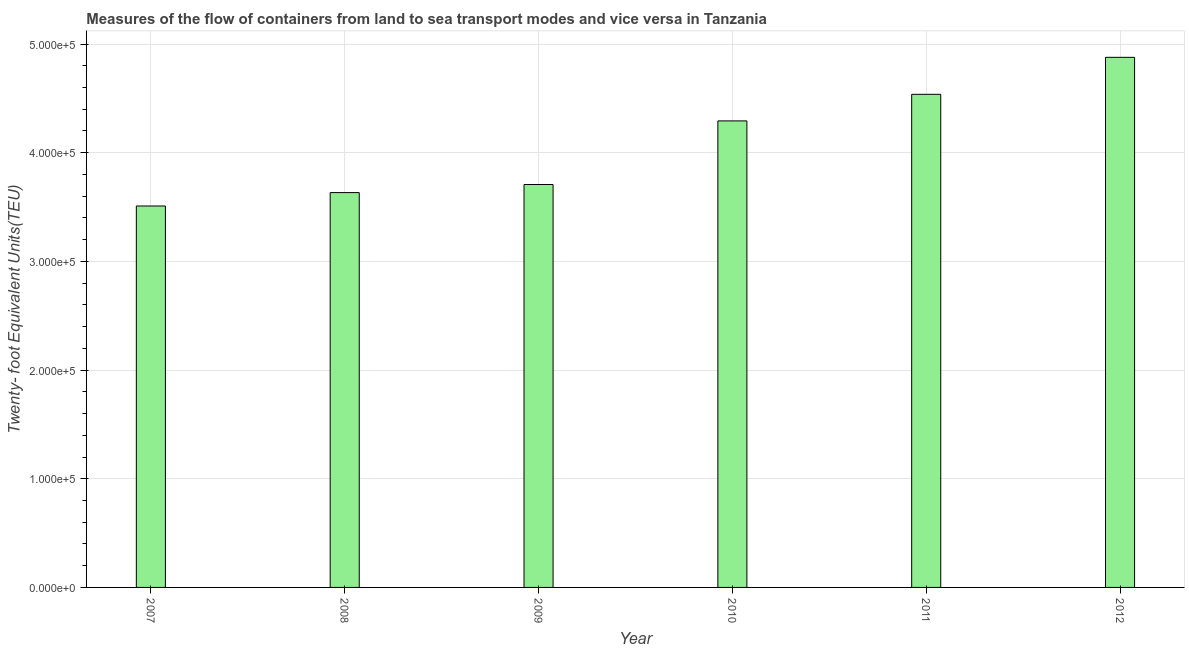What is the title of the graph?
Give a very brief answer. Measures of the flow of containers from land to sea transport modes and vice versa in Tanzania. What is the label or title of the X-axis?
Offer a terse response. Year. What is the label or title of the Y-axis?
Your answer should be compact. Twenty- foot Equivalent Units(TEU). What is the container port traffic in 2009?
Your response must be concise. 3.71e+05. Across all years, what is the maximum container port traffic?
Offer a very short reply. 4.88e+05. Across all years, what is the minimum container port traffic?
Offer a terse response. 3.51e+05. What is the sum of the container port traffic?
Offer a terse response. 2.46e+06. What is the difference between the container port traffic in 2009 and 2011?
Your response must be concise. -8.30e+04. What is the average container port traffic per year?
Offer a very short reply. 4.09e+05. What is the median container port traffic?
Offer a very short reply. 4.00e+05. What is the ratio of the container port traffic in 2007 to that in 2009?
Ensure brevity in your answer.  0.95. What is the difference between the highest and the second highest container port traffic?
Ensure brevity in your answer.  3.40e+04. Is the sum of the container port traffic in 2008 and 2011 greater than the maximum container port traffic across all years?
Offer a very short reply. Yes. What is the difference between the highest and the lowest container port traffic?
Provide a succinct answer. 1.37e+05. How many years are there in the graph?
Your answer should be very brief. 6. What is the difference between two consecutive major ticks on the Y-axis?
Provide a succinct answer. 1.00e+05. What is the Twenty- foot Equivalent Units(TEU) of 2007?
Provide a succinct answer. 3.51e+05. What is the Twenty- foot Equivalent Units(TEU) in 2008?
Provide a short and direct response. 3.63e+05. What is the Twenty- foot Equivalent Units(TEU) in 2009?
Your answer should be very brief. 3.71e+05. What is the Twenty- foot Equivalent Units(TEU) of 2010?
Your answer should be very brief. 4.29e+05. What is the Twenty- foot Equivalent Units(TEU) in 2011?
Offer a very short reply. 4.54e+05. What is the Twenty- foot Equivalent Units(TEU) in 2012?
Your answer should be very brief. 4.88e+05. What is the difference between the Twenty- foot Equivalent Units(TEU) in 2007 and 2008?
Provide a short and direct response. -1.23e+04. What is the difference between the Twenty- foot Equivalent Units(TEU) in 2007 and 2009?
Your response must be concise. -1.98e+04. What is the difference between the Twenty- foot Equivalent Units(TEU) in 2007 and 2010?
Make the answer very short. -7.83e+04. What is the difference between the Twenty- foot Equivalent Units(TEU) in 2007 and 2011?
Provide a succinct answer. -1.03e+05. What is the difference between the Twenty- foot Equivalent Units(TEU) in 2007 and 2012?
Ensure brevity in your answer.  -1.37e+05. What is the difference between the Twenty- foot Equivalent Units(TEU) in 2008 and 2009?
Your answer should be very brief. -7454.7. What is the difference between the Twenty- foot Equivalent Units(TEU) in 2008 and 2010?
Give a very brief answer. -6.60e+04. What is the difference between the Twenty- foot Equivalent Units(TEU) in 2008 and 2011?
Keep it short and to the point. -9.04e+04. What is the difference between the Twenty- foot Equivalent Units(TEU) in 2008 and 2012?
Your response must be concise. -1.24e+05. What is the difference between the Twenty- foot Equivalent Units(TEU) in 2009 and 2010?
Offer a very short reply. -5.85e+04. What is the difference between the Twenty- foot Equivalent Units(TEU) in 2009 and 2011?
Provide a succinct answer. -8.30e+04. What is the difference between the Twenty- foot Equivalent Units(TEU) in 2009 and 2012?
Your answer should be compact. -1.17e+05. What is the difference between the Twenty- foot Equivalent Units(TEU) in 2010 and 2011?
Keep it short and to the point. -2.45e+04. What is the difference between the Twenty- foot Equivalent Units(TEU) in 2010 and 2012?
Your answer should be very brief. -5.85e+04. What is the difference between the Twenty- foot Equivalent Units(TEU) in 2011 and 2012?
Make the answer very short. -3.40e+04. What is the ratio of the Twenty- foot Equivalent Units(TEU) in 2007 to that in 2008?
Keep it short and to the point. 0.97. What is the ratio of the Twenty- foot Equivalent Units(TEU) in 2007 to that in 2009?
Give a very brief answer. 0.95. What is the ratio of the Twenty- foot Equivalent Units(TEU) in 2007 to that in 2010?
Give a very brief answer. 0.82. What is the ratio of the Twenty- foot Equivalent Units(TEU) in 2007 to that in 2011?
Your answer should be very brief. 0.77. What is the ratio of the Twenty- foot Equivalent Units(TEU) in 2007 to that in 2012?
Offer a terse response. 0.72. What is the ratio of the Twenty- foot Equivalent Units(TEU) in 2008 to that in 2009?
Your response must be concise. 0.98. What is the ratio of the Twenty- foot Equivalent Units(TEU) in 2008 to that in 2010?
Your answer should be very brief. 0.85. What is the ratio of the Twenty- foot Equivalent Units(TEU) in 2008 to that in 2011?
Offer a very short reply. 0.8. What is the ratio of the Twenty- foot Equivalent Units(TEU) in 2008 to that in 2012?
Offer a very short reply. 0.74. What is the ratio of the Twenty- foot Equivalent Units(TEU) in 2009 to that in 2010?
Ensure brevity in your answer.  0.86. What is the ratio of the Twenty- foot Equivalent Units(TEU) in 2009 to that in 2011?
Your answer should be very brief. 0.82. What is the ratio of the Twenty- foot Equivalent Units(TEU) in 2009 to that in 2012?
Offer a terse response. 0.76. What is the ratio of the Twenty- foot Equivalent Units(TEU) in 2010 to that in 2011?
Keep it short and to the point. 0.95. What is the ratio of the Twenty- foot Equivalent Units(TEU) in 2011 to that in 2012?
Make the answer very short. 0.93. 